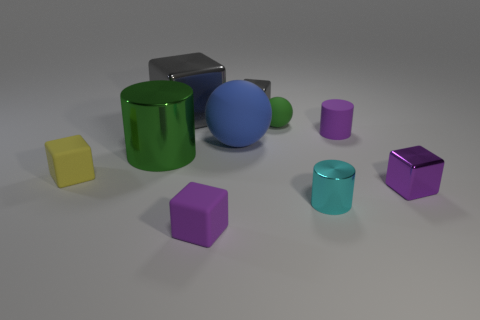What material is the small purple object left of the cyan metal cylinder on the right side of the matte thing that is in front of the yellow thing made of?
Your answer should be very brief. Rubber. How many other objects are the same color as the matte cylinder?
Keep it short and to the point. 2. What number of green things are either small balls or big matte spheres?
Your answer should be compact. 1. What material is the green cylinder that is in front of the blue thing?
Keep it short and to the point. Metal. Is the material of the tiny object to the left of the purple rubber block the same as the tiny ball?
Make the answer very short. Yes. The big rubber object is what shape?
Ensure brevity in your answer.  Sphere. How many large green metal things are behind the gray object to the right of the tiny purple object that is to the left of the large ball?
Offer a terse response. 0. What number of other things are the same material as the cyan object?
Offer a very short reply. 4. There is a blue object that is the same size as the green shiny cylinder; what material is it?
Make the answer very short. Rubber. There is a tiny thing that is to the right of the tiny purple cylinder; is it the same color as the cylinder behind the big green metal thing?
Offer a very short reply. Yes. 